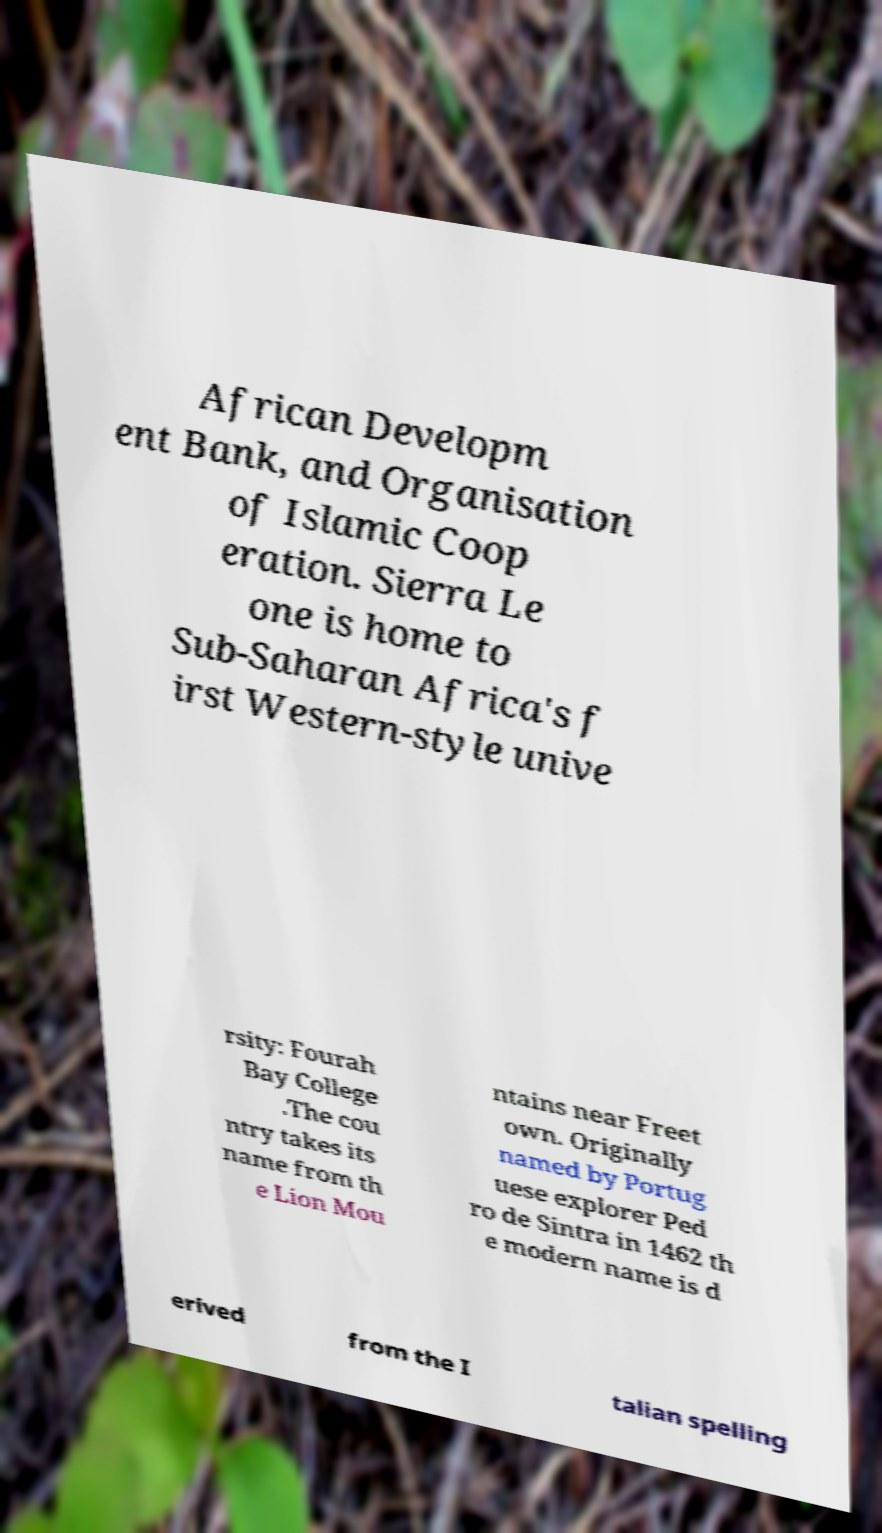I need the written content from this picture converted into text. Can you do that? African Developm ent Bank, and Organisation of Islamic Coop eration. Sierra Le one is home to Sub-Saharan Africa's f irst Western-style unive rsity: Fourah Bay College .The cou ntry takes its name from th e Lion Mou ntains near Freet own. Originally named by Portug uese explorer Ped ro de Sintra in 1462 th e modern name is d erived from the I talian spelling 